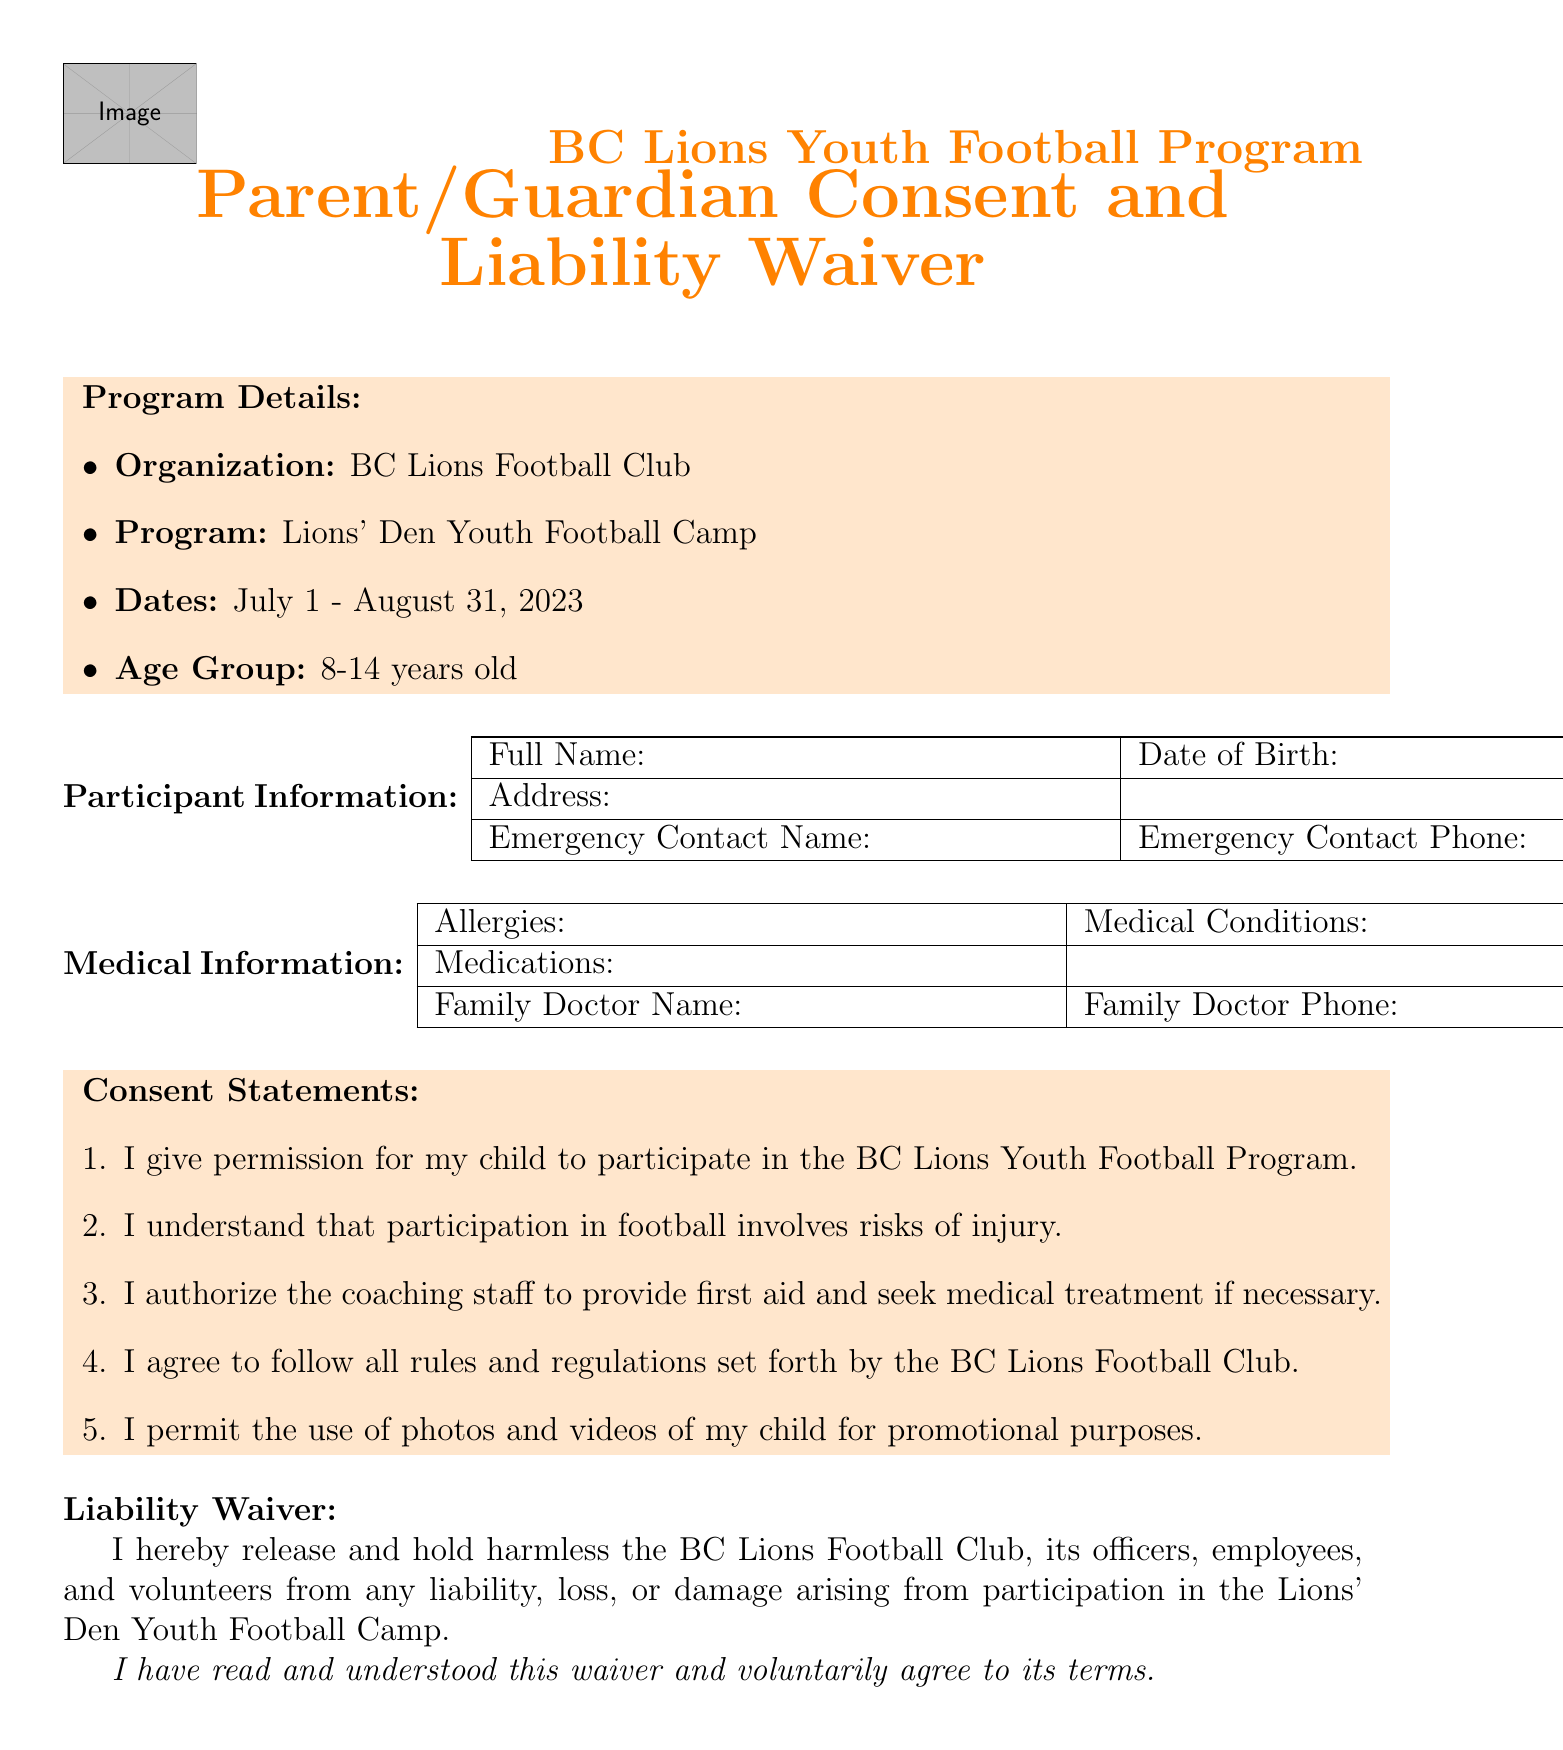What is the name of the program? The program name is mentioned in the document under "Program Details."
Answer: Lions' Den Youth Football Camp What are the season dates for the program? The season dates are listed in the "Program Details" section.
Answer: July 1 - August 31, 2023 Who is the head coach of the program? The head coach's name can be found in the "Coach Information" section.
Answer: Coach Mike Reilly What is the age group for participants? The age group is specified in the "Program Details" section.
Answer: 8-14 years old What is the practice location? The practice location is detailed in the "Venue Information" part of the document.
Answer: BC Place Stadium What is required for participants to bring? The document lists items that participants must bring under "Participant Requirements."
Answer: Mouthguard What does the liability waiver state? The liability waiver text can be found in the relevant section of the document.
Answer: I hereby release and hold harmless the BC Lions Football Club, its officers, employees, and volunteers from any liability, loss, or damage arising from participation in the Lions' Den Youth Football Camp How many assistant coaches are listed? The number of assistant coaches can be counted from the "Coach Information" section.
Answer: 3 What should be returned at the end of the program? The document specifies equipment that must be returned at the end of the program.
Answer: Football cleats 